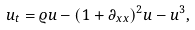Convert formula to latex. <formula><loc_0><loc_0><loc_500><loc_500>u _ { t } = \varrho u - ( 1 + \partial _ { x x } ) ^ { 2 } u - u ^ { 3 } ,</formula> 